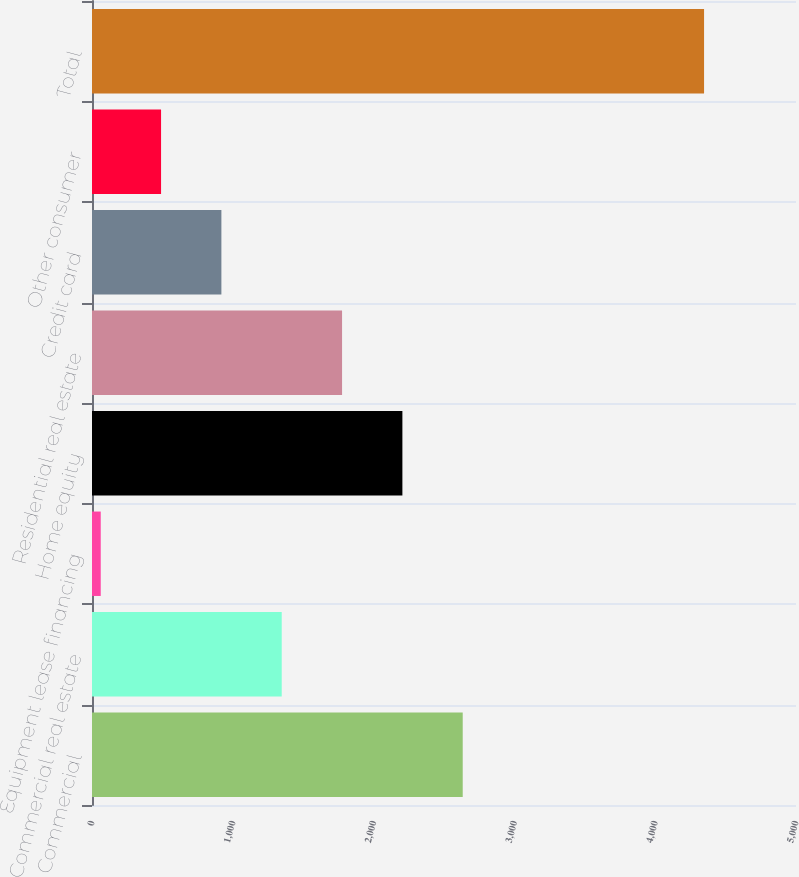Convert chart. <chart><loc_0><loc_0><loc_500><loc_500><bar_chart><fcel>Commercial<fcel>Commercial real estate<fcel>Equipment lease financing<fcel>Home equity<fcel>Residential real estate<fcel>Credit card<fcel>Other consumer<fcel>Total<nl><fcel>2633<fcel>1347.5<fcel>62<fcel>2204.5<fcel>1776<fcel>919<fcel>490.5<fcel>4347<nl></chart> 